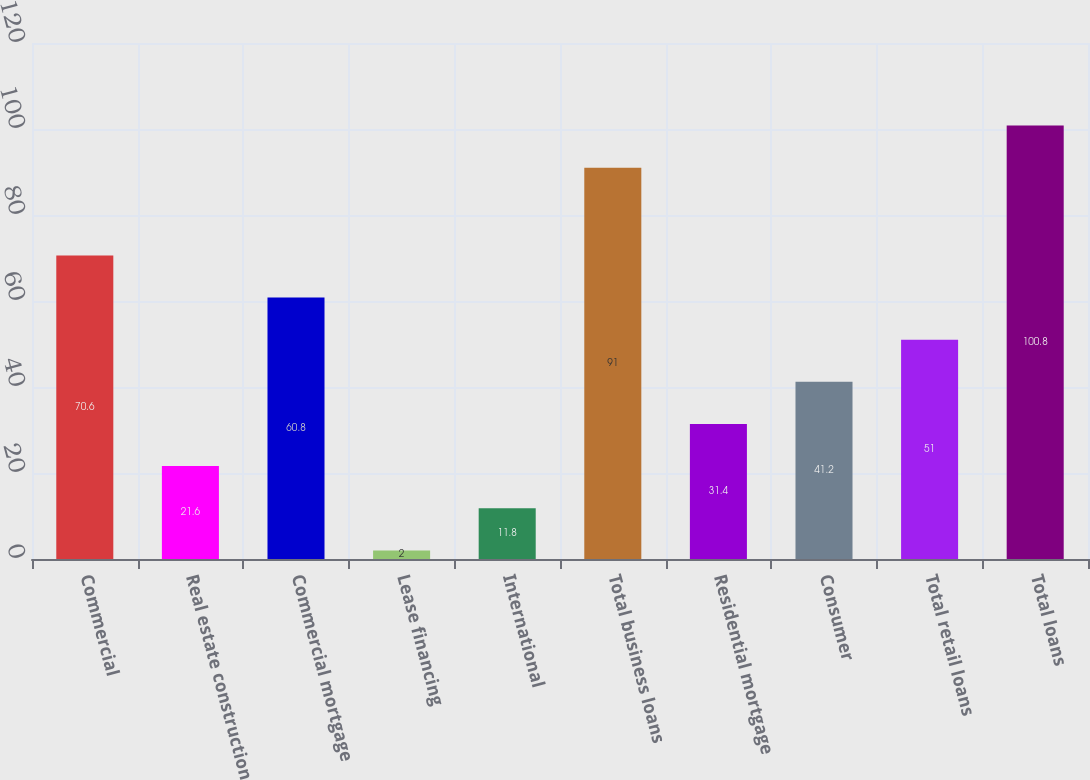Convert chart to OTSL. <chart><loc_0><loc_0><loc_500><loc_500><bar_chart><fcel>Commercial<fcel>Real estate construction<fcel>Commercial mortgage<fcel>Lease financing<fcel>International<fcel>Total business loans<fcel>Residential mortgage<fcel>Consumer<fcel>Total retail loans<fcel>Total loans<nl><fcel>70.6<fcel>21.6<fcel>60.8<fcel>2<fcel>11.8<fcel>91<fcel>31.4<fcel>41.2<fcel>51<fcel>100.8<nl></chart> 